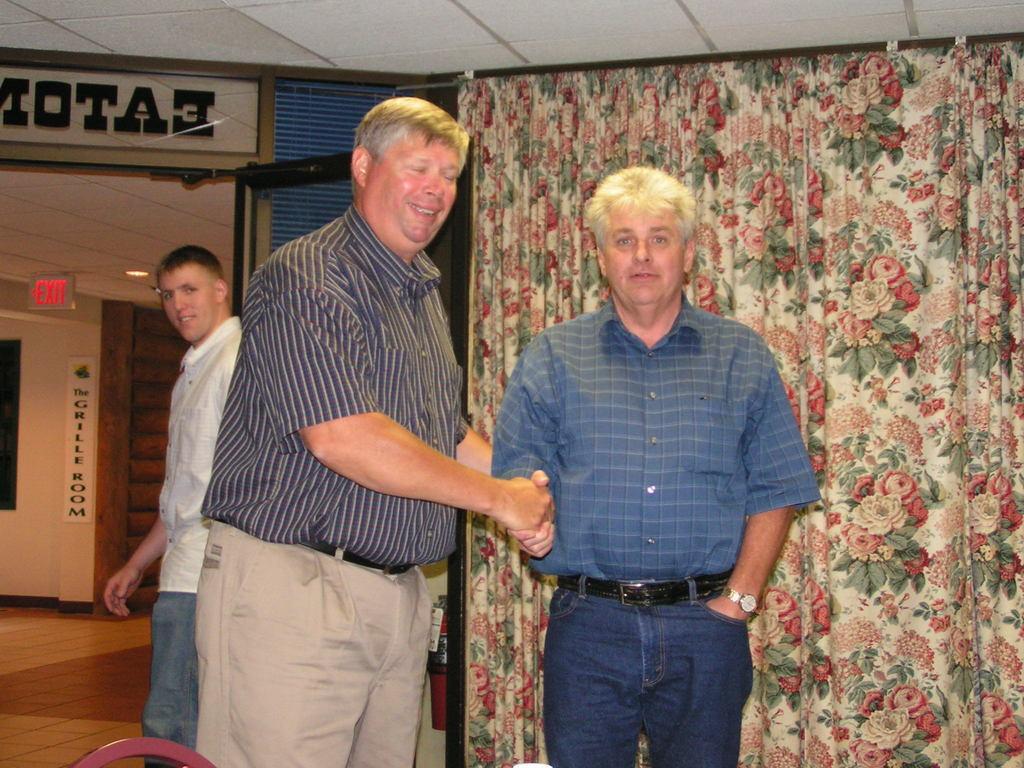Please provide a concise description of this image. In this picture we can see three men are standing, on the right side there is a curtain, in the background we can see a wall, there is a paper pasted on the wall, we can see some text on the paper, there is the ceiling, a light and and an exit board at the top of the picture. 